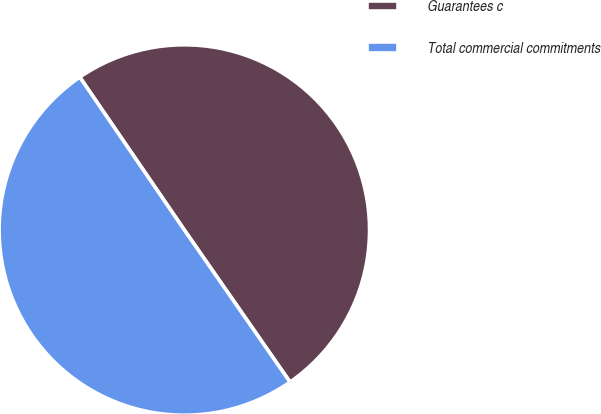Convert chart to OTSL. <chart><loc_0><loc_0><loc_500><loc_500><pie_chart><fcel>Guarantees c<fcel>Total commercial commitments<nl><fcel>49.88%<fcel>50.12%<nl></chart> 